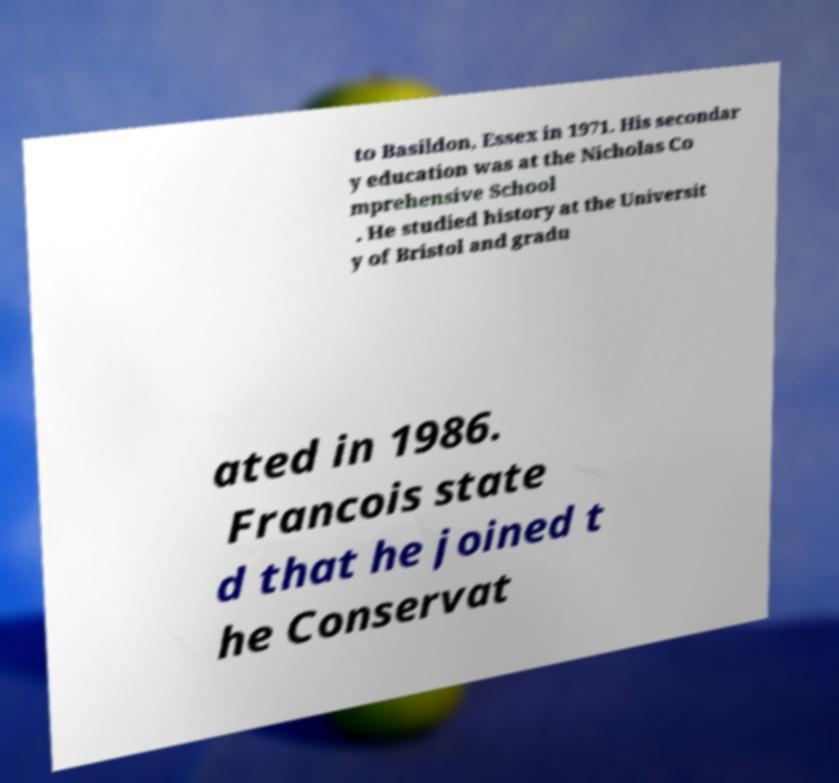I need the written content from this picture converted into text. Can you do that? to Basildon, Essex in 1971. His secondar y education was at the Nicholas Co mprehensive School . He studied history at the Universit y of Bristol and gradu ated in 1986. Francois state d that he joined t he Conservat 